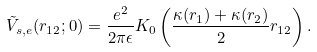Convert formula to latex. <formula><loc_0><loc_0><loc_500><loc_500>\tilde { V } _ { s , e } ( r _ { 1 2 } ; 0 ) = \frac { e ^ { 2 } } { 2 \pi \epsilon } K _ { 0 } \left ( \frac { \kappa ( r _ { 1 } ) + \kappa ( r _ { 2 } ) } { 2 } r _ { 1 2 } \right ) .</formula> 